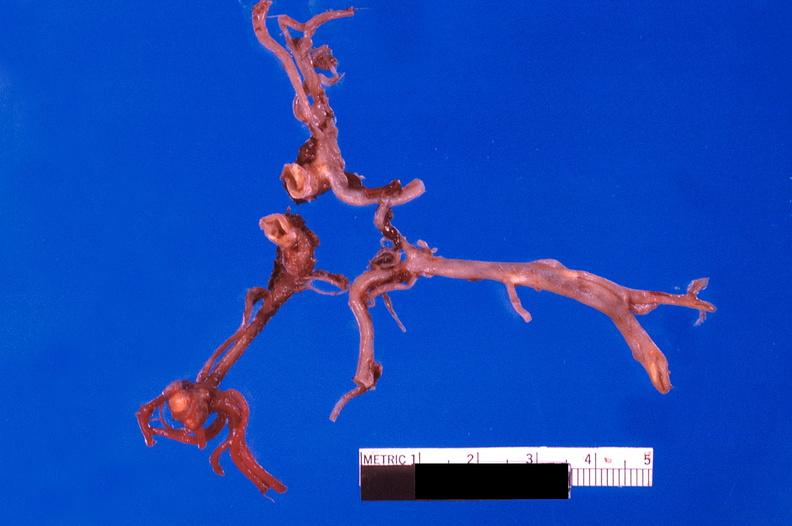what does this image show?
Answer the question using a single word or phrase. Ruptured saccular aneurysm right middle cerebral artery 